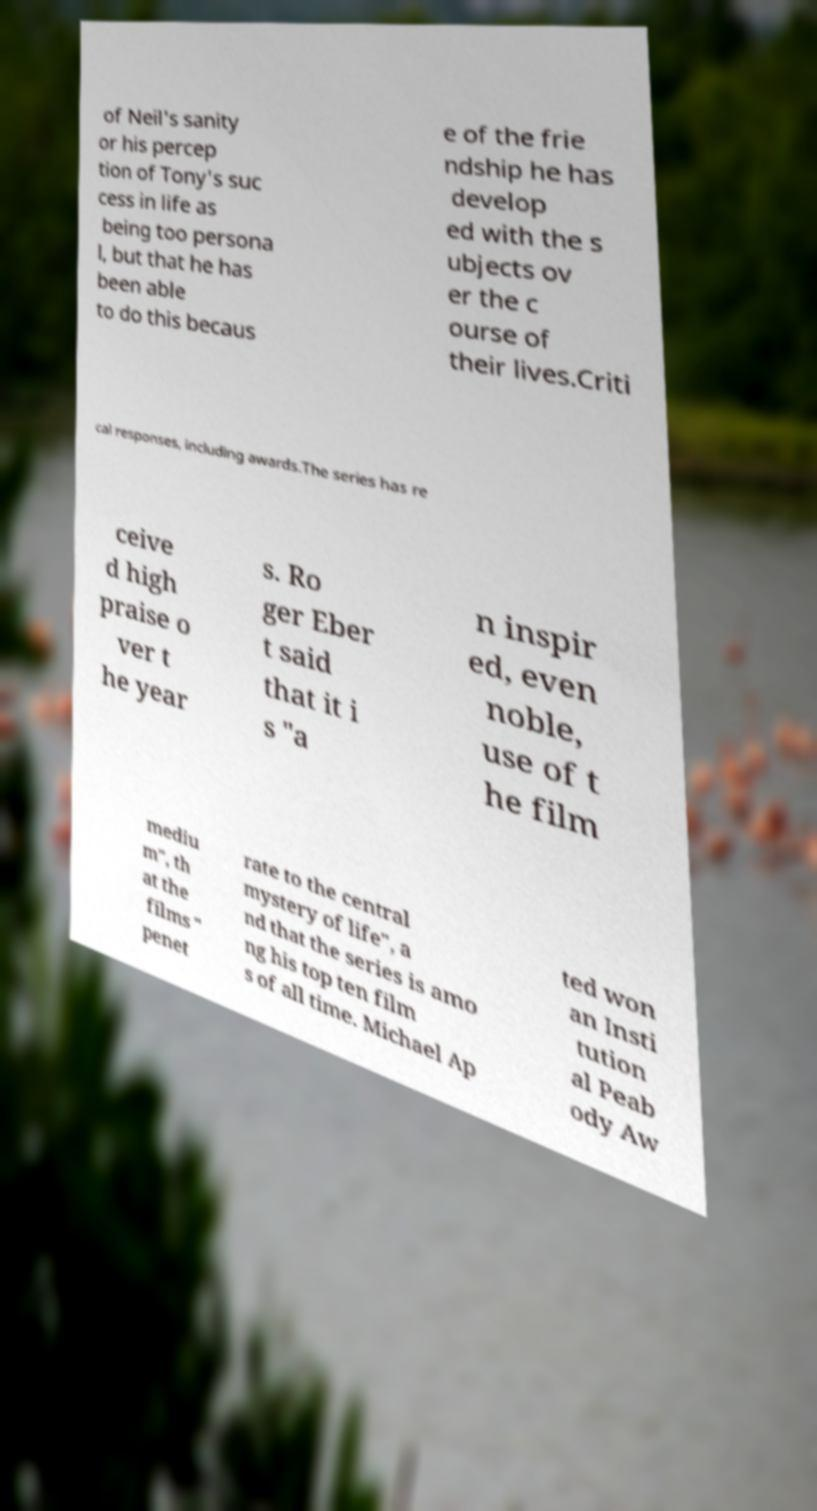I need the written content from this picture converted into text. Can you do that? of Neil's sanity or his percep tion of Tony's suc cess in life as being too persona l, but that he has been able to do this becaus e of the frie ndship he has develop ed with the s ubjects ov er the c ourse of their lives.Criti cal responses, including awards.The series has re ceive d high praise o ver t he year s. Ro ger Eber t said that it i s "a n inspir ed, even noble, use of t he film mediu m", th at the films " penet rate to the central mystery of life", a nd that the series is amo ng his top ten film s of all time. Michael Ap ted won an Insti tution al Peab ody Aw 